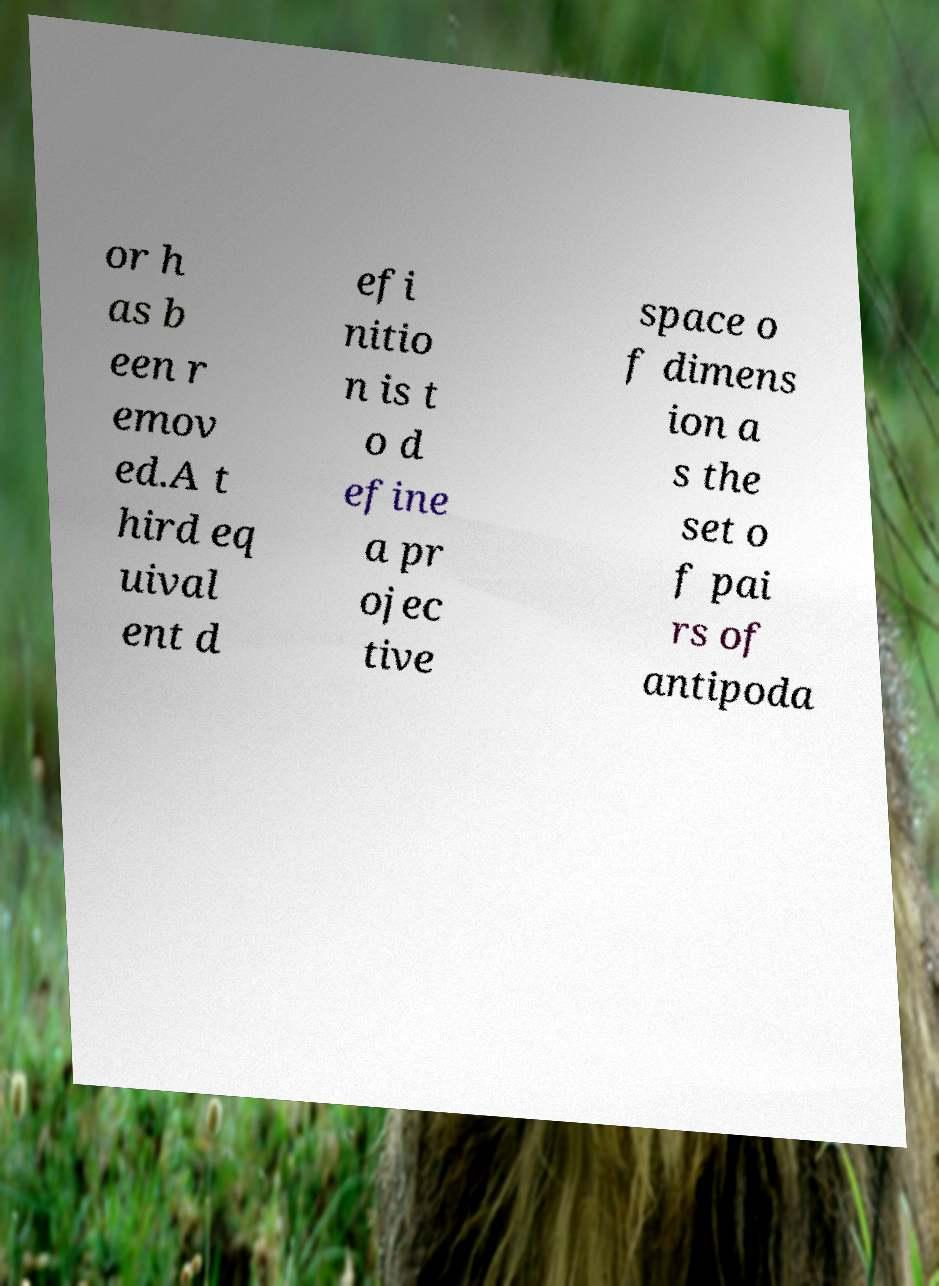Please identify and transcribe the text found in this image. or h as b een r emov ed.A t hird eq uival ent d efi nitio n is t o d efine a pr ojec tive space o f dimens ion a s the set o f pai rs of antipoda 